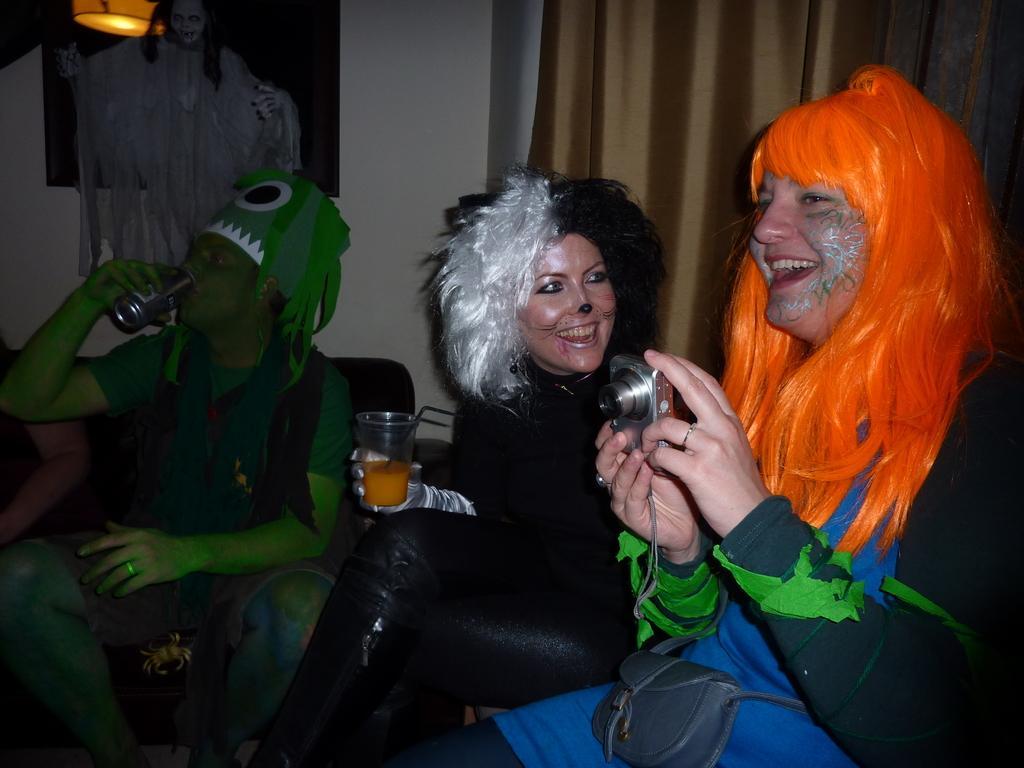Please provide a concise description of this image. In the foreground I can see four persons are sitting on the chairs and are holding glasses, bottle and a camera in hand. In the background I can see a wall, wall painting, light and a curtain. This image is taken in a room. 